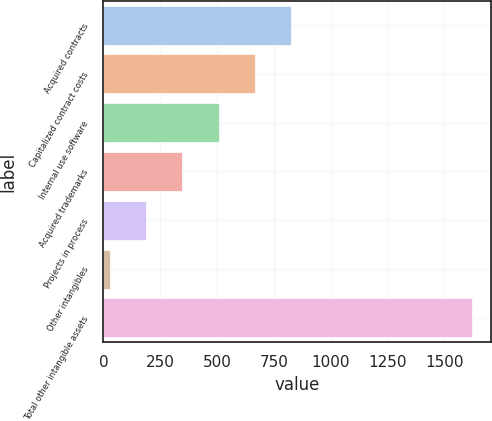Convert chart to OTSL. <chart><loc_0><loc_0><loc_500><loc_500><bar_chart><fcel>Acquired contracts<fcel>Capitalized contract costs<fcel>Internal use software<fcel>Acquired trademarks<fcel>Projects in process<fcel>Other intangibles<fcel>Total other intangible assets<nl><fcel>824.95<fcel>665.46<fcel>505.97<fcel>346.48<fcel>186.99<fcel>27.5<fcel>1622.4<nl></chart> 